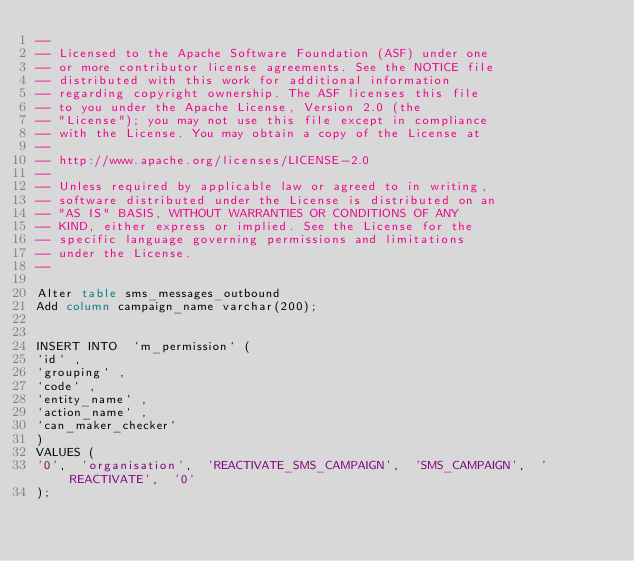<code> <loc_0><loc_0><loc_500><loc_500><_SQL_>--
-- Licensed to the Apache Software Foundation (ASF) under one
-- or more contributor license agreements. See the NOTICE file
-- distributed with this work for additional information
-- regarding copyright ownership. The ASF licenses this file
-- to you under the Apache License, Version 2.0 (the
-- "License"); you may not use this file except in compliance
-- with the License. You may obtain a copy of the License at
--
-- http://www.apache.org/licenses/LICENSE-2.0
--
-- Unless required by applicable law or agreed to in writing,
-- software distributed under the License is distributed on an
-- "AS IS" BASIS, WITHOUT WARRANTIES OR CONDITIONS OF ANY
-- KIND, either express or implied. See the License for the
-- specific language governing permissions and limitations
-- under the License.
--

Alter table sms_messages_outbound
Add column campaign_name varchar(200);


INSERT INTO  `m_permission` (
`id` ,
`grouping` ,
`code` ,
`entity_name` ,
`action_name` ,
`can_maker_checker`
)
VALUES (
'0',  'organisation',  'REACTIVATE_SMS_CAMPAIGN',  'SMS_CAMPAIGN',  'REACTIVATE',  '0'
);
</code> 